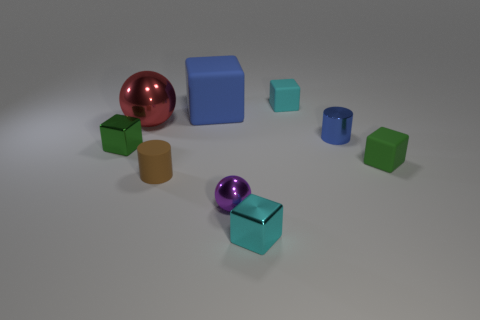There is a metal cube that is behind the green cube to the right of the red shiny sphere that is on the left side of the large blue thing; what is its size?
Ensure brevity in your answer.  Small. There is a brown cylinder; what number of blue metallic objects are to the left of it?
Offer a very short reply. 0. What is the cyan thing behind the tiny matte object that is on the right side of the blue metallic object made of?
Make the answer very short. Rubber. Does the matte cylinder have the same size as the cyan metal cube?
Your answer should be very brief. Yes. What number of objects are either cylinders that are on the right side of the purple ball or blue objects in front of the big metallic sphere?
Your answer should be compact. 1. Are there more green objects to the left of the large red object than tiny cyan matte cubes?
Offer a very short reply. No. How many other things are there of the same shape as the tiny cyan metal thing?
Offer a terse response. 4. There is a tiny cube that is both in front of the green metal thing and left of the small metallic cylinder; what material is it?
Your response must be concise. Metal. How many objects are either large red things or large cyan matte balls?
Provide a short and direct response. 1. Are there more large red metal balls than metal objects?
Provide a short and direct response. No. 